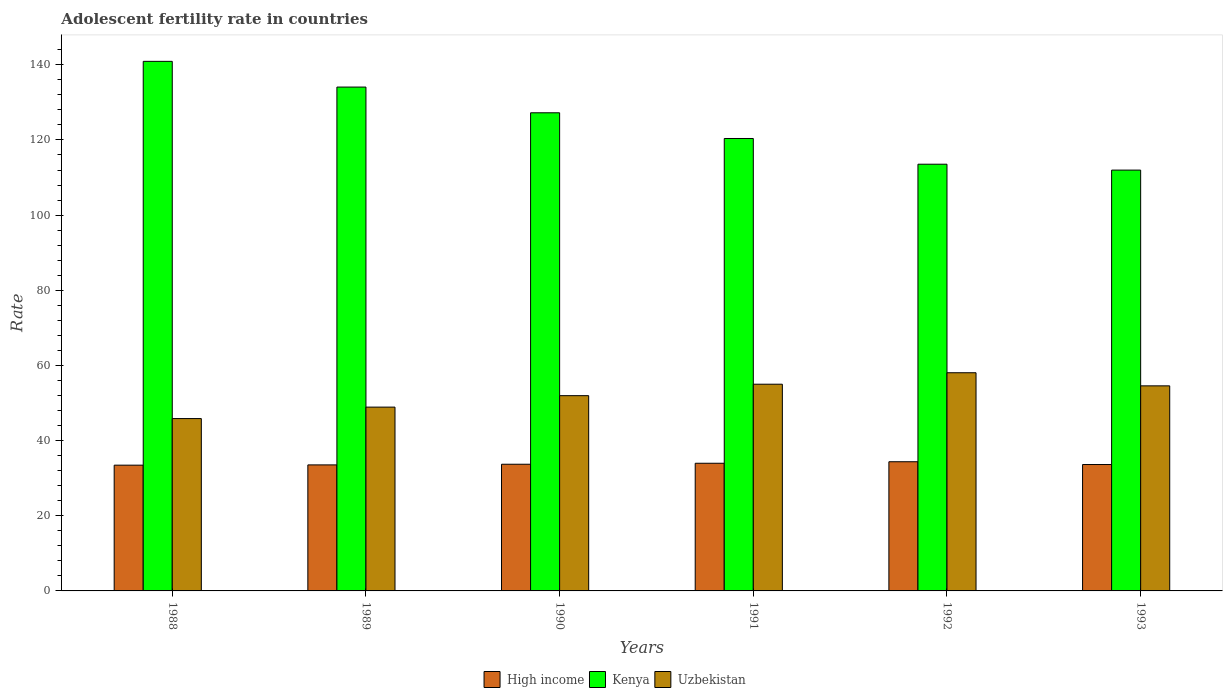How many groups of bars are there?
Offer a very short reply. 6. Are the number of bars per tick equal to the number of legend labels?
Ensure brevity in your answer.  Yes. Are the number of bars on each tick of the X-axis equal?
Give a very brief answer. Yes. What is the label of the 2nd group of bars from the left?
Give a very brief answer. 1989. What is the adolescent fertility rate in High income in 1988?
Your response must be concise. 33.46. Across all years, what is the maximum adolescent fertility rate in Kenya?
Ensure brevity in your answer.  140.92. Across all years, what is the minimum adolescent fertility rate in Kenya?
Make the answer very short. 111.98. In which year was the adolescent fertility rate in High income maximum?
Offer a terse response. 1992. What is the total adolescent fertility rate in High income in the graph?
Make the answer very short. 202.69. What is the difference between the adolescent fertility rate in Kenya in 1988 and that in 1989?
Ensure brevity in your answer.  6.84. What is the difference between the adolescent fertility rate in Kenya in 1993 and the adolescent fertility rate in Uzbekistan in 1990?
Provide a succinct answer. 60.02. What is the average adolescent fertility rate in Kenya per year?
Offer a very short reply. 124.69. In the year 1993, what is the difference between the adolescent fertility rate in High income and adolescent fertility rate in Uzbekistan?
Provide a succinct answer. -20.93. What is the ratio of the adolescent fertility rate in Uzbekistan in 1990 to that in 1992?
Make the answer very short. 0.89. Is the difference between the adolescent fertility rate in High income in 1992 and 1993 greater than the difference between the adolescent fertility rate in Uzbekistan in 1992 and 1993?
Your response must be concise. No. What is the difference between the highest and the second highest adolescent fertility rate in High income?
Provide a short and direct response. 0.4. What is the difference between the highest and the lowest adolescent fertility rate in Kenya?
Give a very brief answer. 28.94. Is the sum of the adolescent fertility rate in Uzbekistan in 1992 and 1993 greater than the maximum adolescent fertility rate in High income across all years?
Offer a very short reply. Yes. What does the 1st bar from the left in 1990 represents?
Your response must be concise. High income. What does the 2nd bar from the right in 1988 represents?
Make the answer very short. Kenya. Are all the bars in the graph horizontal?
Offer a terse response. No. What is the title of the graph?
Your answer should be very brief. Adolescent fertility rate in countries. Does "Small states" appear as one of the legend labels in the graph?
Make the answer very short. No. What is the label or title of the X-axis?
Your response must be concise. Years. What is the label or title of the Y-axis?
Your answer should be compact. Rate. What is the Rate in High income in 1988?
Your response must be concise. 33.46. What is the Rate in Kenya in 1988?
Ensure brevity in your answer.  140.92. What is the Rate of Uzbekistan in 1988?
Give a very brief answer. 45.86. What is the Rate of High income in 1989?
Provide a short and direct response. 33.54. What is the Rate of Kenya in 1989?
Offer a terse response. 134.07. What is the Rate in Uzbekistan in 1989?
Provide a succinct answer. 48.91. What is the Rate of High income in 1990?
Your response must be concise. 33.71. What is the Rate of Kenya in 1990?
Provide a short and direct response. 127.23. What is the Rate in Uzbekistan in 1990?
Offer a terse response. 51.96. What is the Rate of High income in 1991?
Provide a succinct answer. 33.97. What is the Rate of Kenya in 1991?
Keep it short and to the point. 120.39. What is the Rate in Uzbekistan in 1991?
Keep it short and to the point. 55.01. What is the Rate in High income in 1992?
Make the answer very short. 34.37. What is the Rate of Kenya in 1992?
Your answer should be compact. 113.55. What is the Rate in Uzbekistan in 1992?
Give a very brief answer. 58.05. What is the Rate of High income in 1993?
Your answer should be very brief. 33.63. What is the Rate of Kenya in 1993?
Offer a very short reply. 111.98. What is the Rate of Uzbekistan in 1993?
Ensure brevity in your answer.  54.57. Across all years, what is the maximum Rate of High income?
Give a very brief answer. 34.37. Across all years, what is the maximum Rate of Kenya?
Your answer should be compact. 140.92. Across all years, what is the maximum Rate in Uzbekistan?
Provide a short and direct response. 58.05. Across all years, what is the minimum Rate of High income?
Give a very brief answer. 33.46. Across all years, what is the minimum Rate of Kenya?
Make the answer very short. 111.98. Across all years, what is the minimum Rate of Uzbekistan?
Make the answer very short. 45.86. What is the total Rate in High income in the graph?
Keep it short and to the point. 202.69. What is the total Rate in Kenya in the graph?
Give a very brief answer. 748.13. What is the total Rate of Uzbekistan in the graph?
Your answer should be very brief. 314.36. What is the difference between the Rate in High income in 1988 and that in 1989?
Keep it short and to the point. -0.07. What is the difference between the Rate of Kenya in 1988 and that in 1989?
Offer a very short reply. 6.84. What is the difference between the Rate of Uzbekistan in 1988 and that in 1989?
Offer a very short reply. -3.05. What is the difference between the Rate in High income in 1988 and that in 1990?
Offer a very short reply. -0.25. What is the difference between the Rate of Kenya in 1988 and that in 1990?
Give a very brief answer. 13.69. What is the difference between the Rate in Uzbekistan in 1988 and that in 1990?
Provide a short and direct response. -6.1. What is the difference between the Rate of High income in 1988 and that in 1991?
Offer a very short reply. -0.51. What is the difference between the Rate in Kenya in 1988 and that in 1991?
Your answer should be very brief. 20.53. What is the difference between the Rate of Uzbekistan in 1988 and that in 1991?
Offer a terse response. -9.15. What is the difference between the Rate in High income in 1988 and that in 1992?
Make the answer very short. -0.91. What is the difference between the Rate of Kenya in 1988 and that in 1992?
Your response must be concise. 27.37. What is the difference between the Rate in Uzbekistan in 1988 and that in 1992?
Offer a terse response. -12.19. What is the difference between the Rate of High income in 1988 and that in 1993?
Your response must be concise. -0.17. What is the difference between the Rate in Kenya in 1988 and that in 1993?
Keep it short and to the point. 28.94. What is the difference between the Rate of Uzbekistan in 1988 and that in 1993?
Make the answer very short. -8.71. What is the difference between the Rate of High income in 1989 and that in 1990?
Your answer should be very brief. -0.17. What is the difference between the Rate in Kenya in 1989 and that in 1990?
Give a very brief answer. 6.84. What is the difference between the Rate in Uzbekistan in 1989 and that in 1990?
Give a very brief answer. -3.05. What is the difference between the Rate in High income in 1989 and that in 1991?
Your answer should be compact. -0.44. What is the difference between the Rate in Kenya in 1989 and that in 1991?
Give a very brief answer. 13.69. What is the difference between the Rate of Uzbekistan in 1989 and that in 1991?
Offer a terse response. -6.1. What is the difference between the Rate in High income in 1989 and that in 1992?
Ensure brevity in your answer.  -0.84. What is the difference between the Rate in Kenya in 1989 and that in 1992?
Provide a short and direct response. 20.53. What is the difference between the Rate of Uzbekistan in 1989 and that in 1992?
Ensure brevity in your answer.  -9.15. What is the difference between the Rate of High income in 1989 and that in 1993?
Keep it short and to the point. -0.1. What is the difference between the Rate of Kenya in 1989 and that in 1993?
Your answer should be very brief. 22.1. What is the difference between the Rate of Uzbekistan in 1989 and that in 1993?
Provide a succinct answer. -5.66. What is the difference between the Rate of High income in 1990 and that in 1991?
Your response must be concise. -0.26. What is the difference between the Rate of Kenya in 1990 and that in 1991?
Make the answer very short. 6.84. What is the difference between the Rate in Uzbekistan in 1990 and that in 1991?
Your response must be concise. -3.05. What is the difference between the Rate in High income in 1990 and that in 1992?
Offer a very short reply. -0.66. What is the difference between the Rate of Kenya in 1990 and that in 1992?
Your answer should be very brief. 13.69. What is the difference between the Rate of Uzbekistan in 1990 and that in 1992?
Offer a very short reply. -6.1. What is the difference between the Rate of High income in 1990 and that in 1993?
Offer a terse response. 0.07. What is the difference between the Rate in Kenya in 1990 and that in 1993?
Your answer should be very brief. 15.25. What is the difference between the Rate of Uzbekistan in 1990 and that in 1993?
Your response must be concise. -2.61. What is the difference between the Rate in High income in 1991 and that in 1992?
Give a very brief answer. -0.4. What is the difference between the Rate of Kenya in 1991 and that in 1992?
Offer a terse response. 6.84. What is the difference between the Rate in Uzbekistan in 1991 and that in 1992?
Your response must be concise. -3.05. What is the difference between the Rate of High income in 1991 and that in 1993?
Keep it short and to the point. 0.34. What is the difference between the Rate in Kenya in 1991 and that in 1993?
Offer a very short reply. 8.41. What is the difference between the Rate of Uzbekistan in 1991 and that in 1993?
Give a very brief answer. 0.44. What is the difference between the Rate of High income in 1992 and that in 1993?
Your answer should be very brief. 0.74. What is the difference between the Rate in Kenya in 1992 and that in 1993?
Give a very brief answer. 1.57. What is the difference between the Rate of Uzbekistan in 1992 and that in 1993?
Make the answer very short. 3.49. What is the difference between the Rate in High income in 1988 and the Rate in Kenya in 1989?
Offer a terse response. -100.61. What is the difference between the Rate of High income in 1988 and the Rate of Uzbekistan in 1989?
Provide a succinct answer. -15.45. What is the difference between the Rate in Kenya in 1988 and the Rate in Uzbekistan in 1989?
Ensure brevity in your answer.  92.01. What is the difference between the Rate in High income in 1988 and the Rate in Kenya in 1990?
Give a very brief answer. -93.77. What is the difference between the Rate of High income in 1988 and the Rate of Uzbekistan in 1990?
Your answer should be compact. -18.5. What is the difference between the Rate of Kenya in 1988 and the Rate of Uzbekistan in 1990?
Provide a short and direct response. 88.96. What is the difference between the Rate of High income in 1988 and the Rate of Kenya in 1991?
Give a very brief answer. -86.93. What is the difference between the Rate of High income in 1988 and the Rate of Uzbekistan in 1991?
Provide a succinct answer. -21.54. What is the difference between the Rate of Kenya in 1988 and the Rate of Uzbekistan in 1991?
Ensure brevity in your answer.  85.91. What is the difference between the Rate of High income in 1988 and the Rate of Kenya in 1992?
Give a very brief answer. -80.08. What is the difference between the Rate in High income in 1988 and the Rate in Uzbekistan in 1992?
Provide a succinct answer. -24.59. What is the difference between the Rate of Kenya in 1988 and the Rate of Uzbekistan in 1992?
Your response must be concise. 82.86. What is the difference between the Rate in High income in 1988 and the Rate in Kenya in 1993?
Your response must be concise. -78.51. What is the difference between the Rate of High income in 1988 and the Rate of Uzbekistan in 1993?
Provide a short and direct response. -21.1. What is the difference between the Rate of Kenya in 1988 and the Rate of Uzbekistan in 1993?
Your answer should be compact. 86.35. What is the difference between the Rate in High income in 1989 and the Rate in Kenya in 1990?
Keep it short and to the point. -93.7. What is the difference between the Rate of High income in 1989 and the Rate of Uzbekistan in 1990?
Keep it short and to the point. -18.42. What is the difference between the Rate of Kenya in 1989 and the Rate of Uzbekistan in 1990?
Ensure brevity in your answer.  82.12. What is the difference between the Rate in High income in 1989 and the Rate in Kenya in 1991?
Offer a very short reply. -86.85. What is the difference between the Rate of High income in 1989 and the Rate of Uzbekistan in 1991?
Offer a terse response. -21.47. What is the difference between the Rate in Kenya in 1989 and the Rate in Uzbekistan in 1991?
Offer a very short reply. 79.07. What is the difference between the Rate in High income in 1989 and the Rate in Kenya in 1992?
Offer a terse response. -80.01. What is the difference between the Rate in High income in 1989 and the Rate in Uzbekistan in 1992?
Your answer should be very brief. -24.52. What is the difference between the Rate of Kenya in 1989 and the Rate of Uzbekistan in 1992?
Provide a short and direct response. 76.02. What is the difference between the Rate in High income in 1989 and the Rate in Kenya in 1993?
Make the answer very short. -78.44. What is the difference between the Rate of High income in 1989 and the Rate of Uzbekistan in 1993?
Your response must be concise. -21.03. What is the difference between the Rate in Kenya in 1989 and the Rate in Uzbekistan in 1993?
Your answer should be very brief. 79.51. What is the difference between the Rate of High income in 1990 and the Rate of Kenya in 1991?
Offer a terse response. -86.68. What is the difference between the Rate in High income in 1990 and the Rate in Uzbekistan in 1991?
Keep it short and to the point. -21.3. What is the difference between the Rate of Kenya in 1990 and the Rate of Uzbekistan in 1991?
Give a very brief answer. 72.22. What is the difference between the Rate of High income in 1990 and the Rate of Kenya in 1992?
Give a very brief answer. -79.84. What is the difference between the Rate of High income in 1990 and the Rate of Uzbekistan in 1992?
Your answer should be very brief. -24.35. What is the difference between the Rate in Kenya in 1990 and the Rate in Uzbekistan in 1992?
Give a very brief answer. 69.18. What is the difference between the Rate of High income in 1990 and the Rate of Kenya in 1993?
Keep it short and to the point. -78.27. What is the difference between the Rate in High income in 1990 and the Rate in Uzbekistan in 1993?
Keep it short and to the point. -20.86. What is the difference between the Rate of Kenya in 1990 and the Rate of Uzbekistan in 1993?
Keep it short and to the point. 72.66. What is the difference between the Rate in High income in 1991 and the Rate in Kenya in 1992?
Provide a short and direct response. -79.57. What is the difference between the Rate in High income in 1991 and the Rate in Uzbekistan in 1992?
Offer a very short reply. -24.08. What is the difference between the Rate of Kenya in 1991 and the Rate of Uzbekistan in 1992?
Keep it short and to the point. 62.33. What is the difference between the Rate of High income in 1991 and the Rate of Kenya in 1993?
Keep it short and to the point. -78. What is the difference between the Rate in High income in 1991 and the Rate in Uzbekistan in 1993?
Provide a short and direct response. -20.59. What is the difference between the Rate of Kenya in 1991 and the Rate of Uzbekistan in 1993?
Your answer should be compact. 65.82. What is the difference between the Rate in High income in 1992 and the Rate in Kenya in 1993?
Offer a terse response. -77.6. What is the difference between the Rate of High income in 1992 and the Rate of Uzbekistan in 1993?
Offer a terse response. -20.19. What is the difference between the Rate in Kenya in 1992 and the Rate in Uzbekistan in 1993?
Your response must be concise. 58.98. What is the average Rate of High income per year?
Offer a very short reply. 33.78. What is the average Rate in Kenya per year?
Provide a short and direct response. 124.69. What is the average Rate of Uzbekistan per year?
Make the answer very short. 52.39. In the year 1988, what is the difference between the Rate in High income and Rate in Kenya?
Your answer should be compact. -107.45. In the year 1988, what is the difference between the Rate in High income and Rate in Uzbekistan?
Ensure brevity in your answer.  -12.4. In the year 1988, what is the difference between the Rate of Kenya and Rate of Uzbekistan?
Make the answer very short. 95.06. In the year 1989, what is the difference between the Rate in High income and Rate in Kenya?
Your answer should be compact. -100.54. In the year 1989, what is the difference between the Rate in High income and Rate in Uzbekistan?
Offer a very short reply. -15.37. In the year 1989, what is the difference between the Rate of Kenya and Rate of Uzbekistan?
Your answer should be compact. 85.16. In the year 1990, what is the difference between the Rate of High income and Rate of Kenya?
Ensure brevity in your answer.  -93.52. In the year 1990, what is the difference between the Rate of High income and Rate of Uzbekistan?
Offer a terse response. -18.25. In the year 1990, what is the difference between the Rate in Kenya and Rate in Uzbekistan?
Your answer should be compact. 75.27. In the year 1991, what is the difference between the Rate in High income and Rate in Kenya?
Give a very brief answer. -86.42. In the year 1991, what is the difference between the Rate of High income and Rate of Uzbekistan?
Offer a terse response. -21.03. In the year 1991, what is the difference between the Rate in Kenya and Rate in Uzbekistan?
Make the answer very short. 65.38. In the year 1992, what is the difference between the Rate of High income and Rate of Kenya?
Your answer should be compact. -79.17. In the year 1992, what is the difference between the Rate of High income and Rate of Uzbekistan?
Your response must be concise. -23.68. In the year 1992, what is the difference between the Rate of Kenya and Rate of Uzbekistan?
Provide a succinct answer. 55.49. In the year 1993, what is the difference between the Rate of High income and Rate of Kenya?
Keep it short and to the point. -78.34. In the year 1993, what is the difference between the Rate of High income and Rate of Uzbekistan?
Provide a short and direct response. -20.93. In the year 1993, what is the difference between the Rate of Kenya and Rate of Uzbekistan?
Your answer should be very brief. 57.41. What is the ratio of the Rate in High income in 1988 to that in 1989?
Your answer should be compact. 1. What is the ratio of the Rate in Kenya in 1988 to that in 1989?
Provide a short and direct response. 1.05. What is the ratio of the Rate of Uzbekistan in 1988 to that in 1989?
Your answer should be very brief. 0.94. What is the ratio of the Rate of Kenya in 1988 to that in 1990?
Provide a succinct answer. 1.11. What is the ratio of the Rate of Uzbekistan in 1988 to that in 1990?
Your answer should be very brief. 0.88. What is the ratio of the Rate of Kenya in 1988 to that in 1991?
Offer a very short reply. 1.17. What is the ratio of the Rate of Uzbekistan in 1988 to that in 1991?
Make the answer very short. 0.83. What is the ratio of the Rate of High income in 1988 to that in 1992?
Offer a terse response. 0.97. What is the ratio of the Rate in Kenya in 1988 to that in 1992?
Keep it short and to the point. 1.24. What is the ratio of the Rate of Uzbekistan in 1988 to that in 1992?
Provide a short and direct response. 0.79. What is the ratio of the Rate in High income in 1988 to that in 1993?
Provide a succinct answer. 0.99. What is the ratio of the Rate in Kenya in 1988 to that in 1993?
Ensure brevity in your answer.  1.26. What is the ratio of the Rate of Uzbekistan in 1988 to that in 1993?
Make the answer very short. 0.84. What is the ratio of the Rate of Kenya in 1989 to that in 1990?
Offer a very short reply. 1.05. What is the ratio of the Rate in Uzbekistan in 1989 to that in 1990?
Make the answer very short. 0.94. What is the ratio of the Rate of High income in 1989 to that in 1991?
Your answer should be compact. 0.99. What is the ratio of the Rate in Kenya in 1989 to that in 1991?
Keep it short and to the point. 1.11. What is the ratio of the Rate in Uzbekistan in 1989 to that in 1991?
Your answer should be very brief. 0.89. What is the ratio of the Rate in High income in 1989 to that in 1992?
Make the answer very short. 0.98. What is the ratio of the Rate of Kenya in 1989 to that in 1992?
Your answer should be very brief. 1.18. What is the ratio of the Rate of Uzbekistan in 1989 to that in 1992?
Your answer should be very brief. 0.84. What is the ratio of the Rate of High income in 1989 to that in 1993?
Provide a short and direct response. 1. What is the ratio of the Rate of Kenya in 1989 to that in 1993?
Provide a short and direct response. 1.2. What is the ratio of the Rate of Uzbekistan in 1989 to that in 1993?
Provide a short and direct response. 0.9. What is the ratio of the Rate in Kenya in 1990 to that in 1991?
Make the answer very short. 1.06. What is the ratio of the Rate in Uzbekistan in 1990 to that in 1991?
Your answer should be compact. 0.94. What is the ratio of the Rate of High income in 1990 to that in 1992?
Make the answer very short. 0.98. What is the ratio of the Rate of Kenya in 1990 to that in 1992?
Offer a terse response. 1.12. What is the ratio of the Rate of Uzbekistan in 1990 to that in 1992?
Provide a short and direct response. 0.9. What is the ratio of the Rate in Kenya in 1990 to that in 1993?
Your answer should be very brief. 1.14. What is the ratio of the Rate in Uzbekistan in 1990 to that in 1993?
Keep it short and to the point. 0.95. What is the ratio of the Rate in High income in 1991 to that in 1992?
Provide a succinct answer. 0.99. What is the ratio of the Rate in Kenya in 1991 to that in 1992?
Make the answer very short. 1.06. What is the ratio of the Rate in Uzbekistan in 1991 to that in 1992?
Your response must be concise. 0.95. What is the ratio of the Rate in High income in 1991 to that in 1993?
Your answer should be very brief. 1.01. What is the ratio of the Rate of Kenya in 1991 to that in 1993?
Provide a short and direct response. 1.08. What is the ratio of the Rate of Uzbekistan in 1991 to that in 1993?
Your response must be concise. 1.01. What is the ratio of the Rate in High income in 1992 to that in 1993?
Your answer should be very brief. 1.02. What is the ratio of the Rate of Kenya in 1992 to that in 1993?
Offer a very short reply. 1.01. What is the ratio of the Rate of Uzbekistan in 1992 to that in 1993?
Keep it short and to the point. 1.06. What is the difference between the highest and the second highest Rate in High income?
Ensure brevity in your answer.  0.4. What is the difference between the highest and the second highest Rate of Kenya?
Provide a short and direct response. 6.84. What is the difference between the highest and the second highest Rate of Uzbekistan?
Offer a very short reply. 3.05. What is the difference between the highest and the lowest Rate in High income?
Provide a short and direct response. 0.91. What is the difference between the highest and the lowest Rate of Kenya?
Keep it short and to the point. 28.94. What is the difference between the highest and the lowest Rate in Uzbekistan?
Keep it short and to the point. 12.19. 